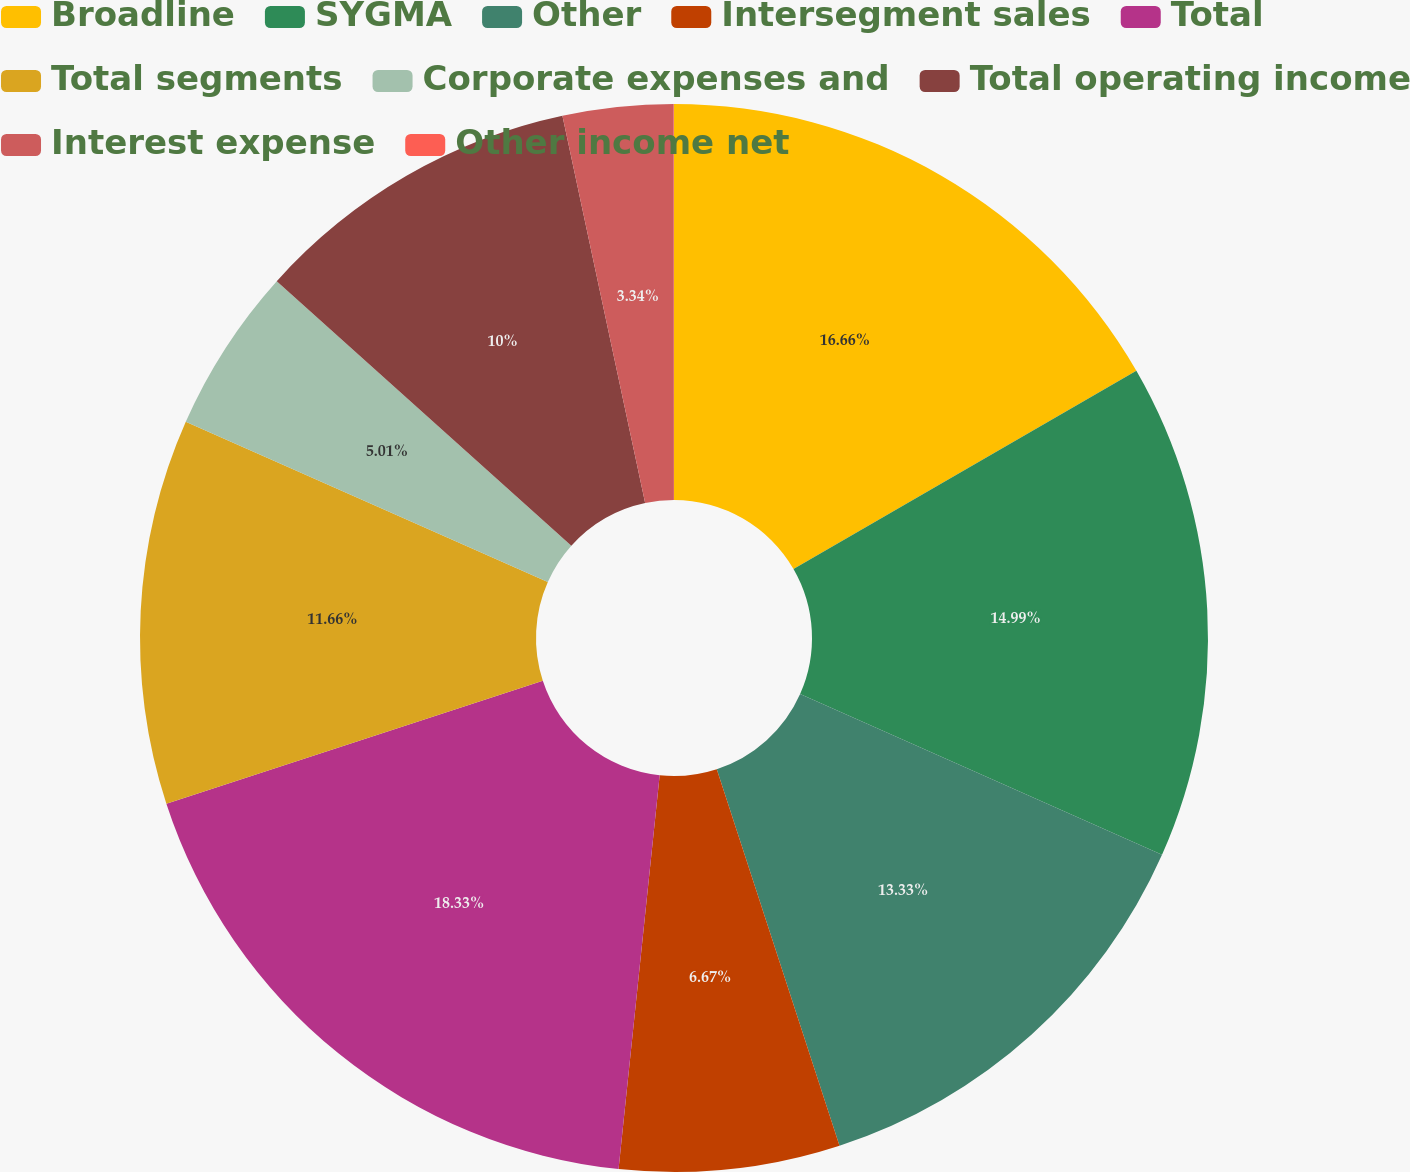Convert chart to OTSL. <chart><loc_0><loc_0><loc_500><loc_500><pie_chart><fcel>Broadline<fcel>SYGMA<fcel>Other<fcel>Intersegment sales<fcel>Total<fcel>Total segments<fcel>Corporate expenses and<fcel>Total operating income<fcel>Interest expense<fcel>Other income net<nl><fcel>16.66%<fcel>14.99%<fcel>13.33%<fcel>6.67%<fcel>18.32%<fcel>11.66%<fcel>5.01%<fcel>10.0%<fcel>3.34%<fcel>0.01%<nl></chart> 